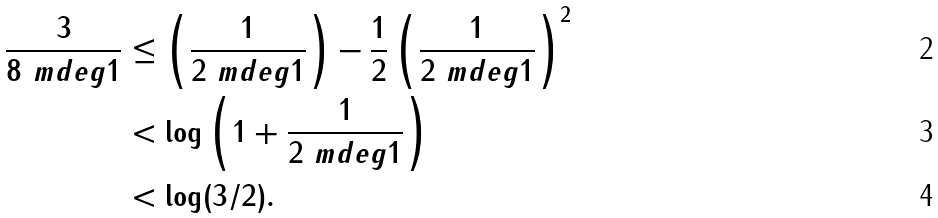<formula> <loc_0><loc_0><loc_500><loc_500>\frac { 3 } { 8 \ m d e g { 1 } } & \leq \left ( \frac { 1 } { 2 \ m d e g { 1 } } \right ) - \frac { 1 } { 2 } \left ( \frac { 1 } { 2 \ m d e g { 1 } } \right ) ^ { 2 } \\ & < \log \left ( 1 + \frac { 1 } { 2 \ m d e g { 1 } } \right ) \\ & < \log ( 3 / 2 ) .</formula> 